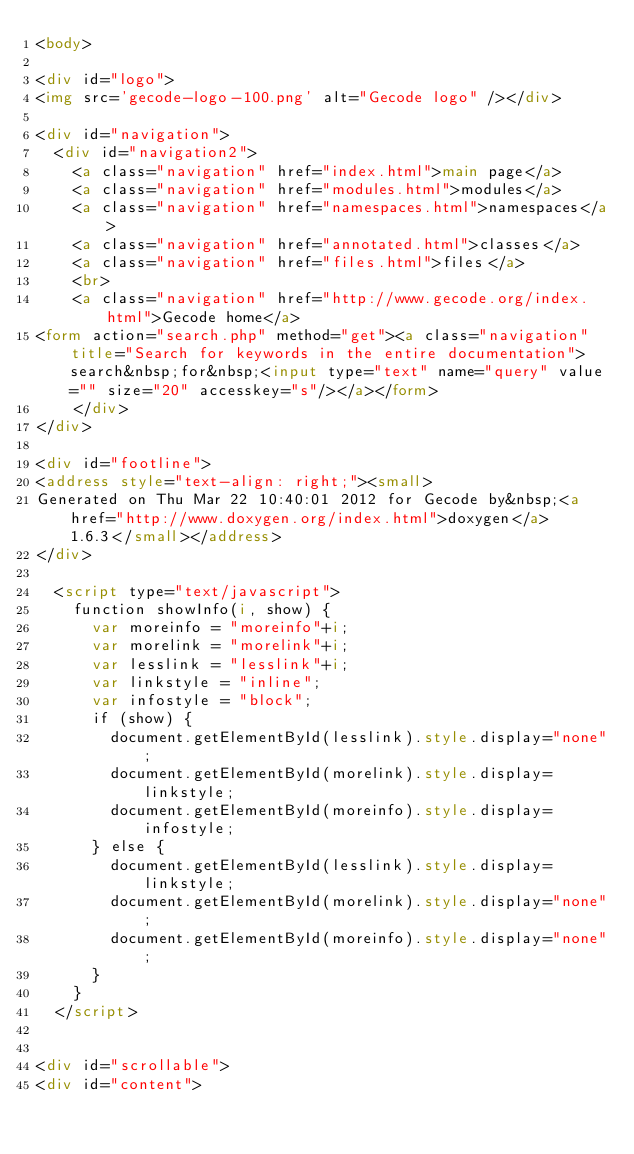Convert code to text. <code><loc_0><loc_0><loc_500><loc_500><_HTML_><body>

<div id="logo">
<img src='gecode-logo-100.png' alt="Gecode logo" /></div>

<div id="navigation">
  <div id="navigation2">
    <a class="navigation" href="index.html">main page</a>
    <a class="navigation" href="modules.html">modules</a>
    <a class="navigation" href="namespaces.html">namespaces</a>
    <a class="navigation" href="annotated.html">classes</a>
    <a class="navigation" href="files.html">files</a>
    <br>
    <a class="navigation" href="http://www.gecode.org/index.html">Gecode home</a>
<form action="search.php" method="get"><a class="navigation" title="Search for keywords in the entire documentation">search&nbsp;for&nbsp;<input type="text" name="query" value="" size="20" accesskey="s"/></a></form>
    </div>
</div>

<div id="footline">
<address style="text-align: right;"><small>
Generated on Thu Mar 22 10:40:01 2012 for Gecode by&nbsp;<a href="http://www.doxygen.org/index.html">doxygen</a> 1.6.3</small></address>
</div>

  <script type="text/javascript">
    function showInfo(i, show) {
      var moreinfo = "moreinfo"+i;
      var morelink = "morelink"+i;
      var lesslink = "lesslink"+i;
      var linkstyle = "inline";
      var infostyle = "block";
      if (show) {
        document.getElementById(lesslink).style.display="none";
        document.getElementById(morelink).style.display=linkstyle;
        document.getElementById(moreinfo).style.display=infostyle;
      } else {
        document.getElementById(lesslink).style.display=linkstyle;        
        document.getElementById(morelink).style.display="none";        
        document.getElementById(moreinfo).style.display="none";        
      }
    }
  </script>


<div id="scrollable">
<div id="content"></code> 